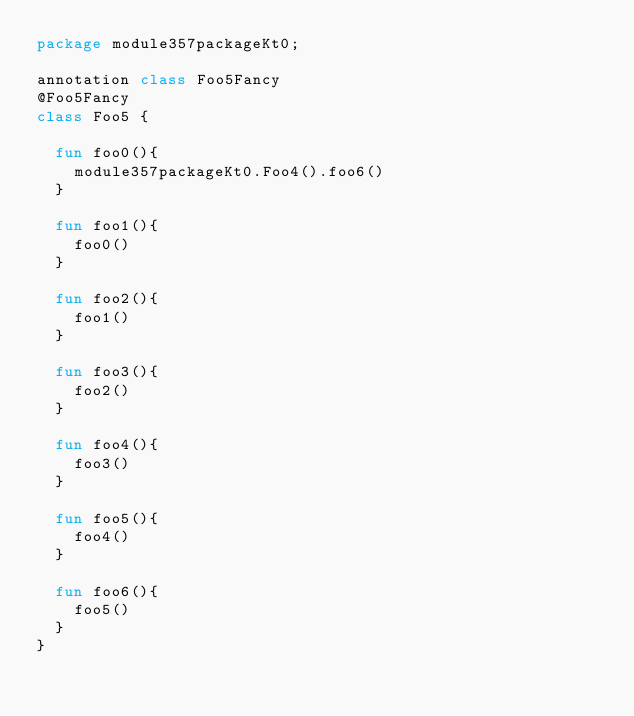Convert code to text. <code><loc_0><loc_0><loc_500><loc_500><_Kotlin_>package module357packageKt0;

annotation class Foo5Fancy
@Foo5Fancy
class Foo5 {

  fun foo0(){
    module357packageKt0.Foo4().foo6()
  }

  fun foo1(){
    foo0()
  }

  fun foo2(){
    foo1()
  }

  fun foo3(){
    foo2()
  }

  fun foo4(){
    foo3()
  }

  fun foo5(){
    foo4()
  }

  fun foo6(){
    foo5()
  }
}</code> 